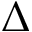Convert formula to latex. <formula><loc_0><loc_0><loc_500><loc_500>\Delta</formula> 